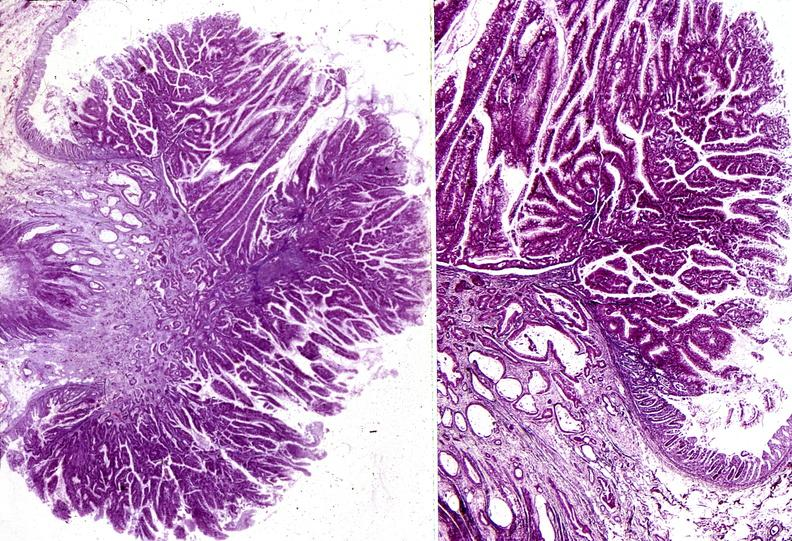s gastrointestinal present?
Answer the question using a single word or phrase. Yes 